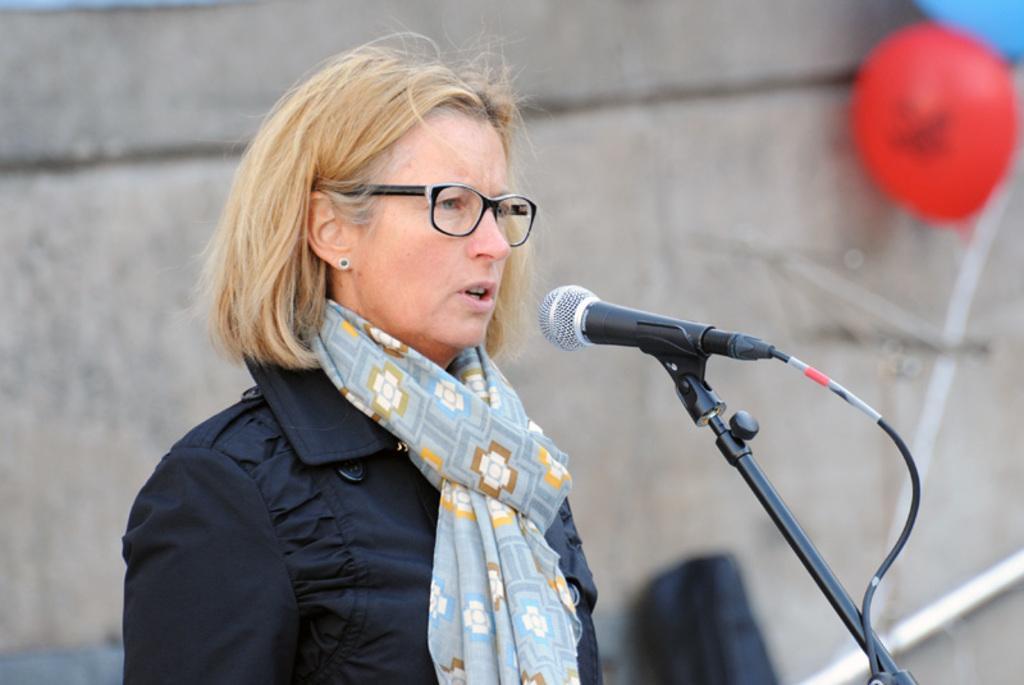Please provide a concise description of this image. In the center of the image, we can see a lady wearing glasses and a scarf and there is a mic in front of her. In the background, there is a wall and we can see balloons. 